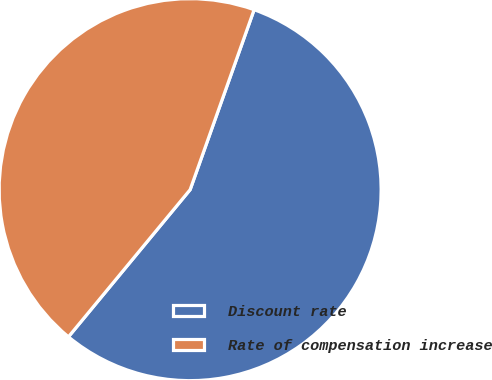Convert chart. <chart><loc_0><loc_0><loc_500><loc_500><pie_chart><fcel>Discount rate<fcel>Rate of compensation increase<nl><fcel>55.56%<fcel>44.44%<nl></chart> 